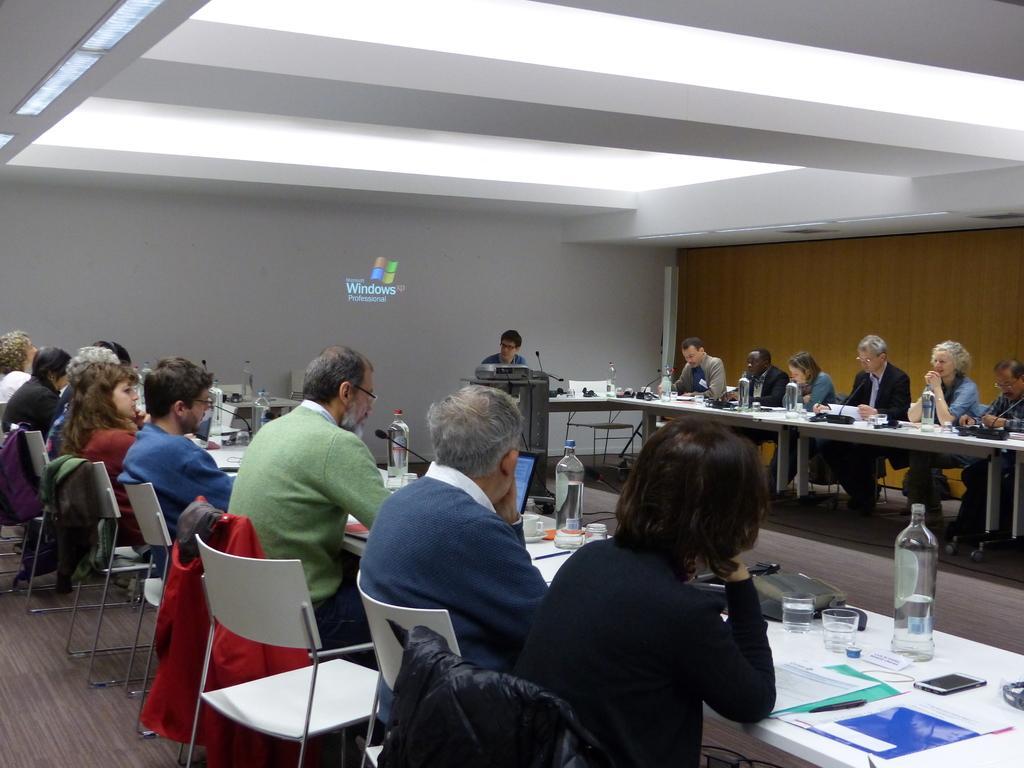How would you summarize this image in a sentence or two? In the picture I can see some people are sitting on the chairs, in front we can see the table on which bottles, papers and few objects are placed, opposite to them one person is talking in front of microphone. 